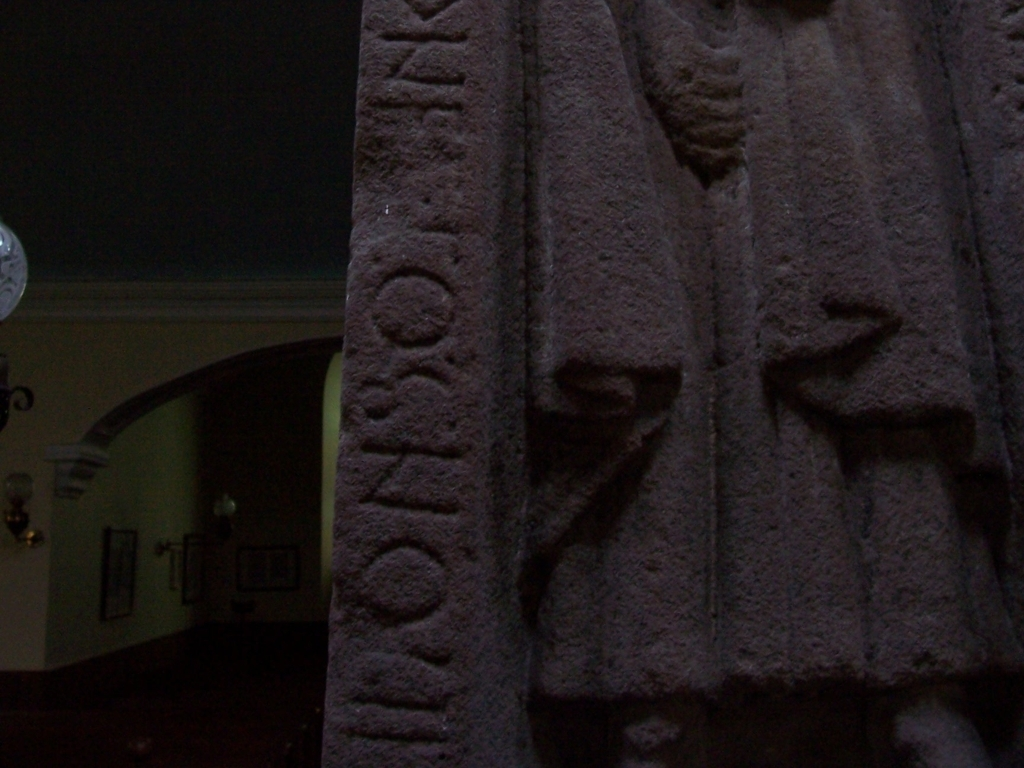Is the quality of this image slightly inferior? Upon reviewing the image, it appears that the quality does indeed seem to be slightly inferior. The image has noticeable graininess and lacks sharpness, which could be a result of low lighting, a low-resolution camera sensor, or motion blur. The readability of the text carved into the stone is compromised, and finer details are lost, making it difficult to fully appreciate any intricate work on the object shown. 